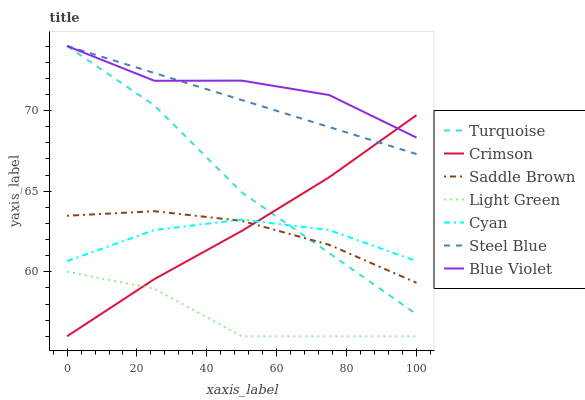Does Light Green have the minimum area under the curve?
Answer yes or no. Yes. Does Blue Violet have the maximum area under the curve?
Answer yes or no. Yes. Does Steel Blue have the minimum area under the curve?
Answer yes or no. No. Does Steel Blue have the maximum area under the curve?
Answer yes or no. No. Is Steel Blue the smoothest?
Answer yes or no. Yes. Is Blue Violet the roughest?
Answer yes or no. Yes. Is Light Green the smoothest?
Answer yes or no. No. Is Light Green the roughest?
Answer yes or no. No. Does Light Green have the lowest value?
Answer yes or no. Yes. Does Steel Blue have the lowest value?
Answer yes or no. No. Does Blue Violet have the highest value?
Answer yes or no. Yes. Does Light Green have the highest value?
Answer yes or no. No. Is Saddle Brown less than Blue Violet?
Answer yes or no. Yes. Is Blue Violet greater than Light Green?
Answer yes or no. Yes. Does Light Green intersect Crimson?
Answer yes or no. Yes. Is Light Green less than Crimson?
Answer yes or no. No. Is Light Green greater than Crimson?
Answer yes or no. No. Does Saddle Brown intersect Blue Violet?
Answer yes or no. No. 